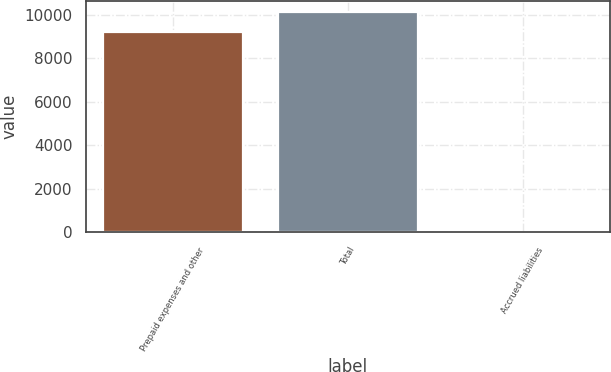Convert chart. <chart><loc_0><loc_0><loc_500><loc_500><bar_chart><fcel>Prepaid expenses and other<fcel>Total<fcel>Accrued liabilities<nl><fcel>9210<fcel>10130.9<fcel>1.39<nl></chart> 